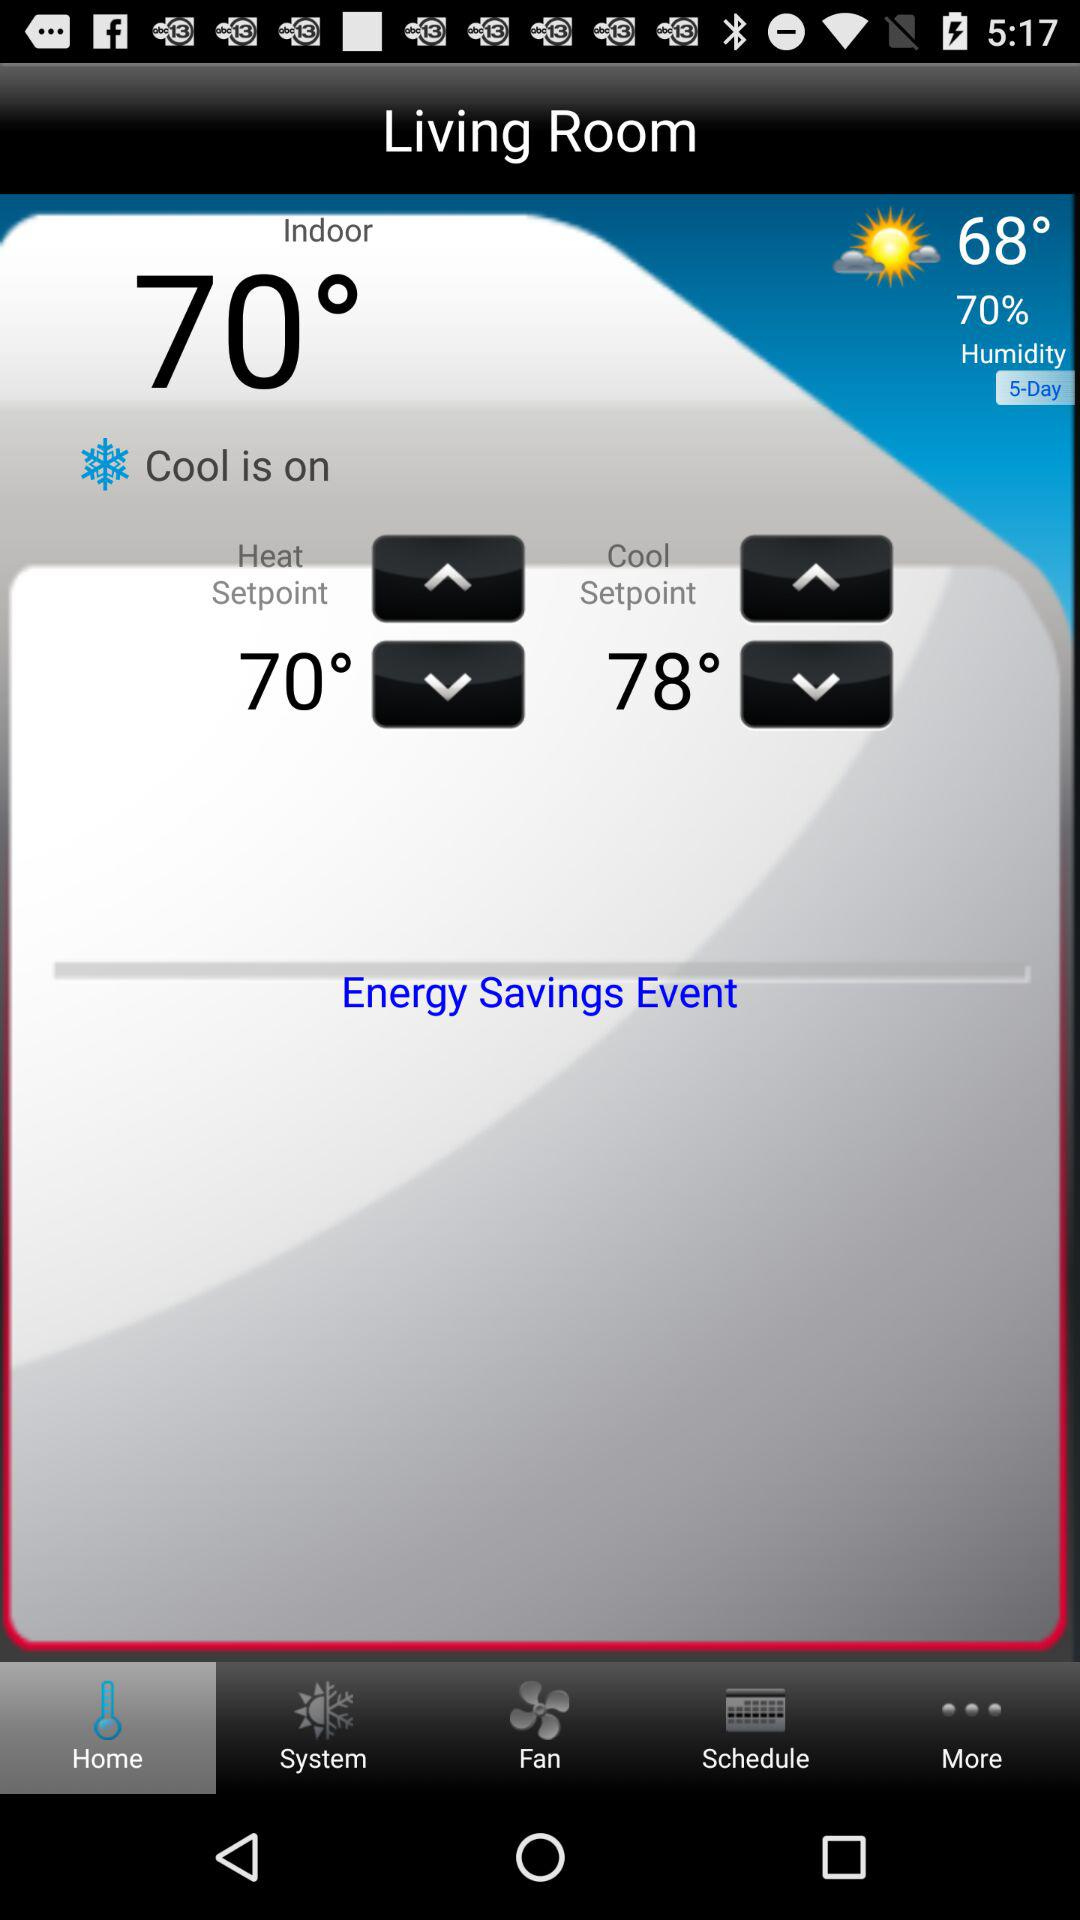What is the temperature? The temperature is 68°. 